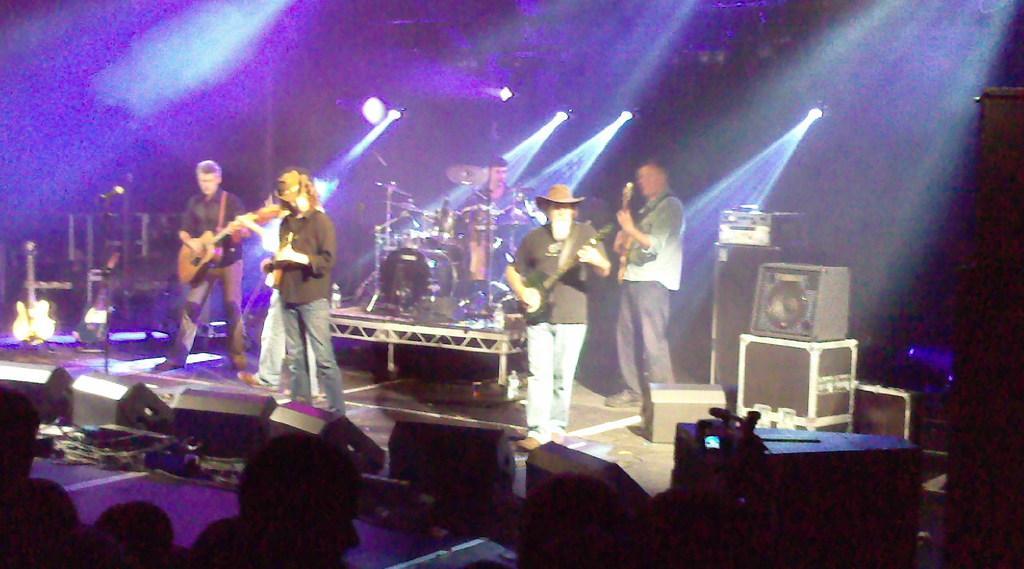Can you describe this image briefly? In the image we can see few persons were standing and holding guitar. Between them they were few musical instruments. In the bottom we can see few persons were standing. In the background there is wall,light and speakers. 